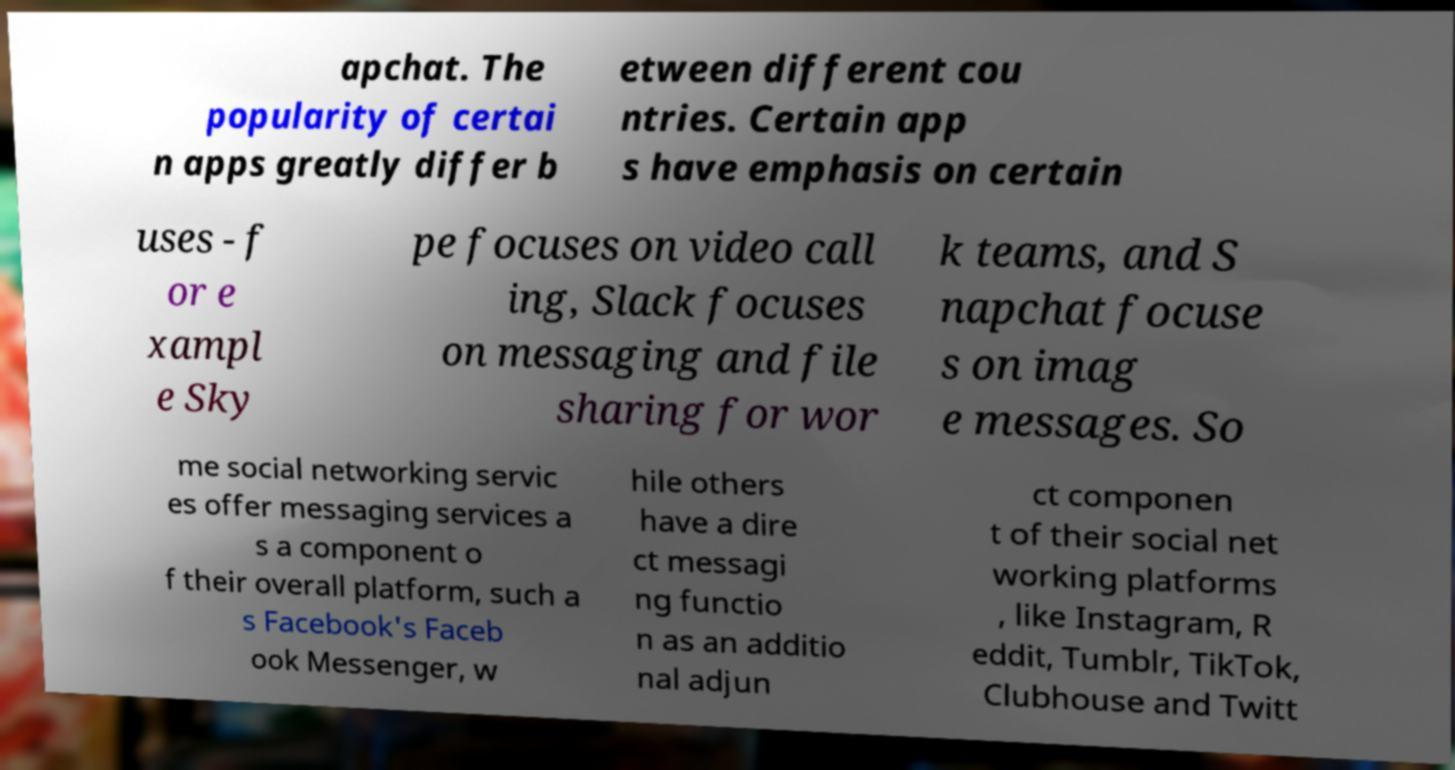Please read and relay the text visible in this image. What does it say? apchat. The popularity of certai n apps greatly differ b etween different cou ntries. Certain app s have emphasis on certain uses - f or e xampl e Sky pe focuses on video call ing, Slack focuses on messaging and file sharing for wor k teams, and S napchat focuse s on imag e messages. So me social networking servic es offer messaging services a s a component o f their overall platform, such a s Facebook's Faceb ook Messenger, w hile others have a dire ct messagi ng functio n as an additio nal adjun ct componen t of their social net working platforms , like Instagram, R eddit, Tumblr, TikTok, Clubhouse and Twitt 